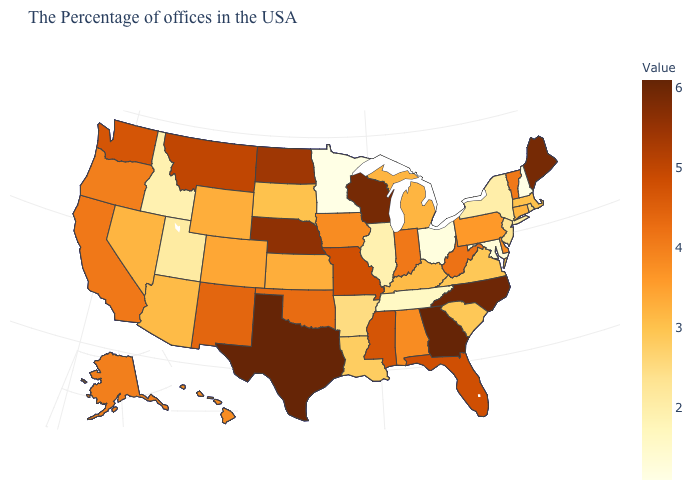Does Georgia have the highest value in the USA?
Be succinct. Yes. Does New Hampshire have the lowest value in the Northeast?
Answer briefly. Yes. Among the states that border Montana , does North Dakota have the lowest value?
Give a very brief answer. No. Among the states that border Georgia , does Florida have the lowest value?
Keep it brief. No. 